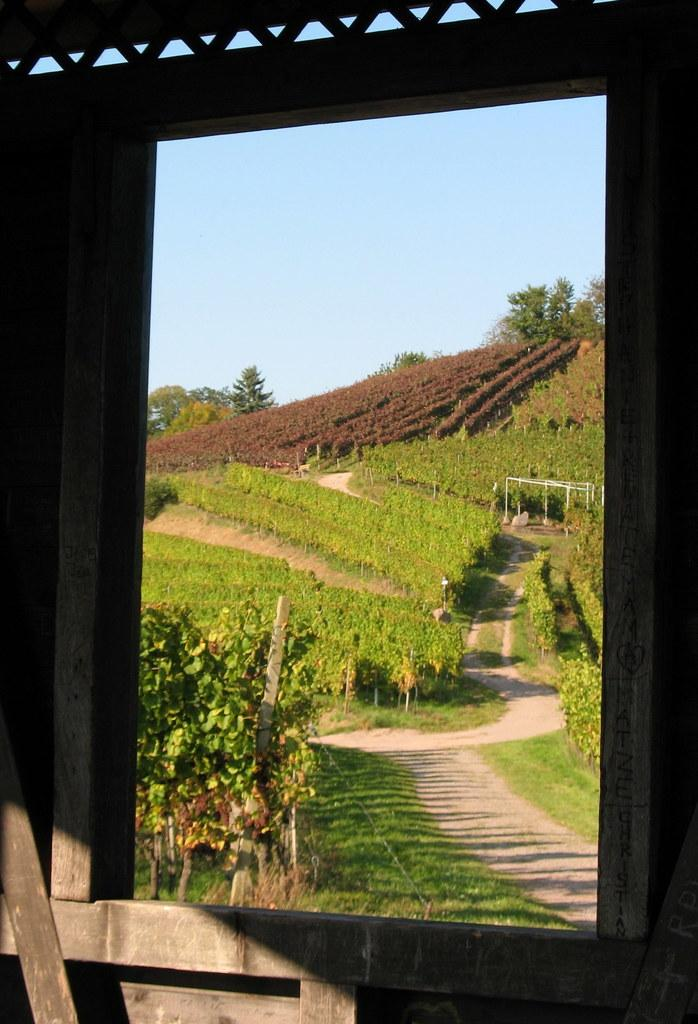What type of wall is present in the image? There is a wooden wall in the image. What feature is included in the wooden wall? There is a window in the wooden wall. What can be seen through the window? Plants, trees, and structures are visible through the window. What is visible in the background of the image? There is a wall in the background of the image. What type of cup is being used for the pollution-reducing activity in the image? There is no cup or pollution-reducing activity present in the image. 